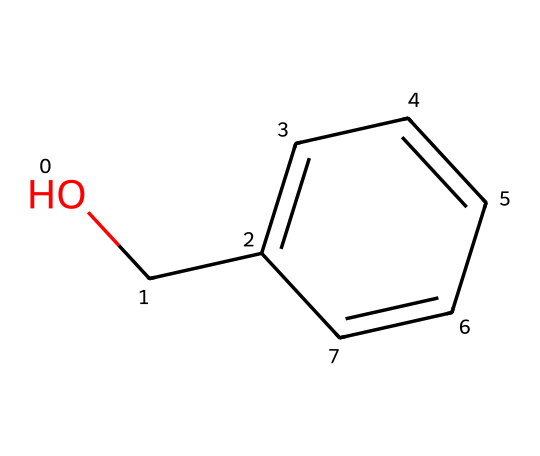What is the name of this compound? The provided SMILES representation corresponds to a chemical structure comprising a hydroxyl group (-OH) bonded to a benzene ring, which is characteristic of benzyl alcohol.
Answer: benzyl alcohol How many carbon atoms are present in this compound? Analyzing the SMILES representation, there are six carbon atoms in the benzene ring and one additional carbon from the hydroxyl group, totaling seven carbon atoms.
Answer: 7 What functional group is present in this compound? The visual structure shows a hydroxyl group (-OH) attached to the benzene, which identifies it as an alcohol functional group.
Answer: hydroxyl How many hydrogen atoms are connected to this molecule? Each carbon in the benzene ring can generally bond with one hydrogen atom, and the carbon attached to the hydroxyl group contributes one more, leading to a total of eight hydrogen atoms in benzyl alcohol.
Answer: 8 Is this compound soluble in water? The presence of the hydroxyl group in benzyl alcohol generally enhances its solubility in water due to hydrogen bonding interactions, which is characteristic of alcohols.
Answer: yes What type of compound is benzyl alcohol classified as? Benzyl alcohol, with its aromatic ring and an alcohol functional group, is classified specifically as an aromatic alcohol.
Answer: aromatic alcohol 